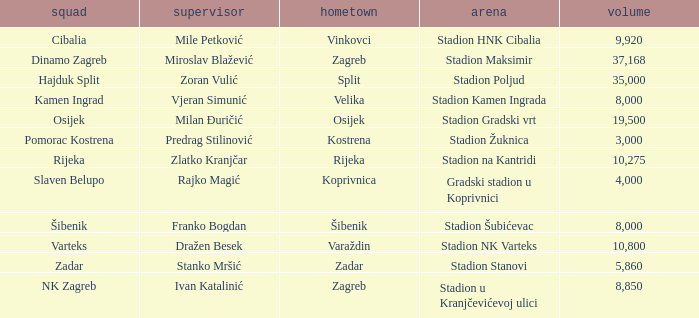What team that has a Home city of Zadar? Zadar. 